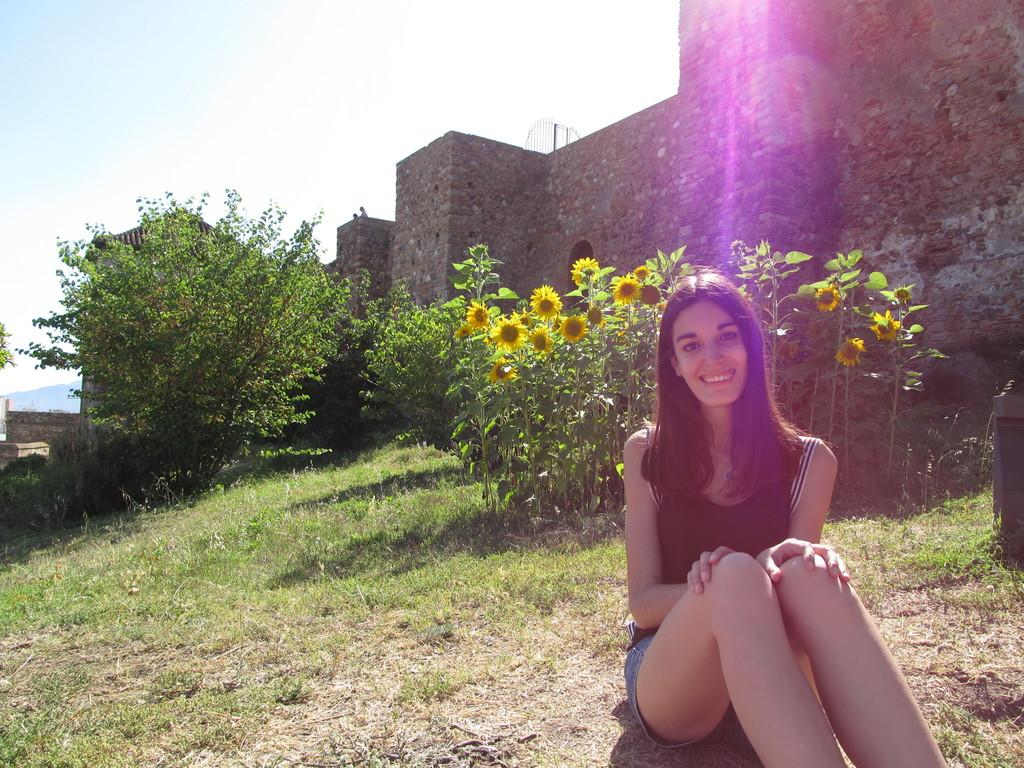What is the person in the image doing? The person is sitting on the grass in the image. What is the person's facial expression? The person is smiling. What type of vegetation can be seen in the image? There are plants and trees in the image. What can be seen in the background of the image? There are buildings and the sky visible in the background of the image. What time of day is it in the image, based on the plant's morning routine? There is no specific plant mentioned in the image, and the time of day cannot be determined based on a plant's morning routine. 